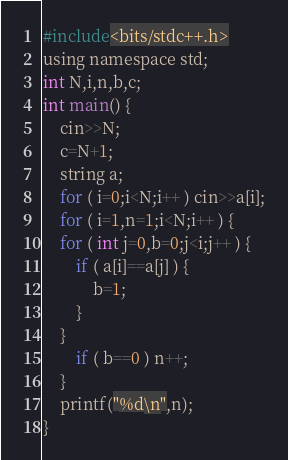<code> <loc_0><loc_0><loc_500><loc_500><_C_>#include<bits/stdc++.h>
using namespace std;
int N,i,n,b,c;
int main() { 
	cin>>N;
	c=N+1;
	string a;
	for ( i=0;i<N;i++ ) cin>>a[i];
	for ( i=1,n=1;i<N;i++ ) {
	for ( int j=0,b=0;j<i;j++ ) {
		if ( a[i]==a[j] ) {
			b=1;
		} 
	}	
		if ( b==0 ) n++; 
	}
	printf("%d\n",n);
}
</code> 